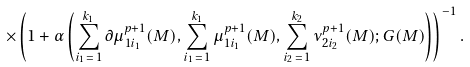<formula> <loc_0><loc_0><loc_500><loc_500>\times \left ( 1 + \alpha \left ( \sum _ { i _ { 1 } \, = \, 1 } ^ { k _ { 1 } } \partial \mu _ { 1 i _ { 1 } } ^ { p + 1 } ( M ) , \sum _ { i _ { 1 } \, = \, 1 } ^ { k _ { 1 } } \mu _ { 1 i _ { 1 } } ^ { p + 1 } ( M ) , \sum _ { i _ { 2 } \, = \, 1 } ^ { k _ { 2 } } \nu _ { 2 i _ { 2 } } ^ { p + 1 } ( M ) ; G ( M ) \right ) \right ) ^ { - 1 } .</formula> 